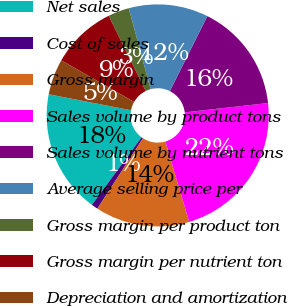Convert chart to OTSL. <chart><loc_0><loc_0><loc_500><loc_500><pie_chart><fcel>Net sales<fcel>Cost of sales<fcel>Gross margin<fcel>Sales volume by product tons<fcel>Sales volume by nutrient tons<fcel>Average selling price per<fcel>Gross margin per product ton<fcel>Gross margin per nutrient ton<fcel>Depreciation and amortization<nl><fcel>17.96%<fcel>0.95%<fcel>13.71%<fcel>22.21%<fcel>15.84%<fcel>11.58%<fcel>3.08%<fcel>9.46%<fcel>5.21%<nl></chart> 